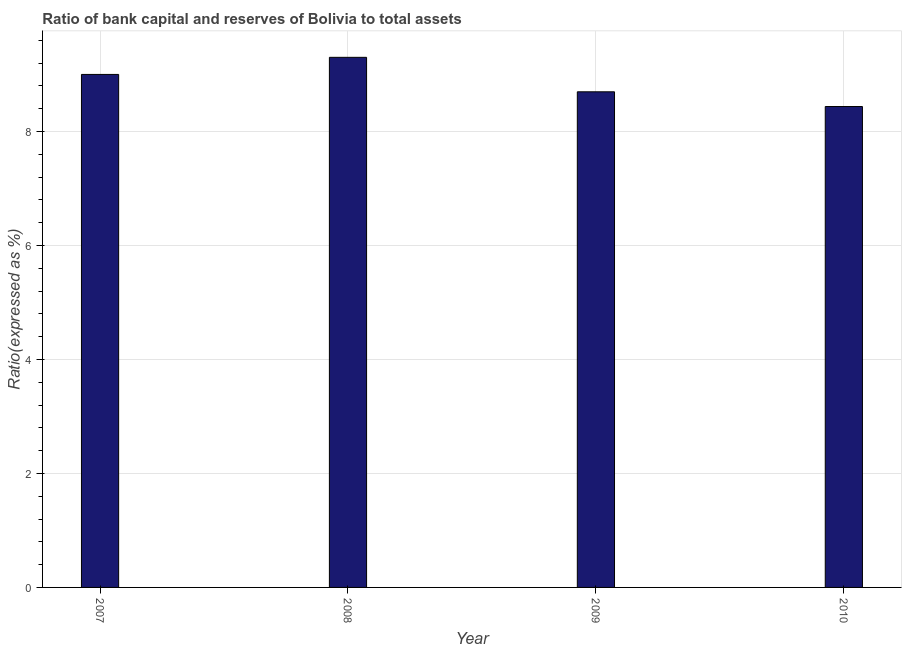What is the title of the graph?
Your answer should be very brief. Ratio of bank capital and reserves of Bolivia to total assets. What is the label or title of the Y-axis?
Provide a succinct answer. Ratio(expressed as %). Across all years, what is the maximum bank capital to assets ratio?
Your answer should be compact. 9.3. Across all years, what is the minimum bank capital to assets ratio?
Ensure brevity in your answer.  8.44. In which year was the bank capital to assets ratio maximum?
Your answer should be very brief. 2008. In which year was the bank capital to assets ratio minimum?
Offer a terse response. 2010. What is the sum of the bank capital to assets ratio?
Your answer should be very brief. 35.43. What is the difference between the bank capital to assets ratio in 2008 and 2010?
Your answer should be very brief. 0.86. What is the average bank capital to assets ratio per year?
Give a very brief answer. 8.86. What is the median bank capital to assets ratio?
Make the answer very short. 8.85. In how many years, is the bank capital to assets ratio greater than 2 %?
Your answer should be compact. 4. Do a majority of the years between 2008 and 2010 (inclusive) have bank capital to assets ratio greater than 8.4 %?
Make the answer very short. Yes. What is the ratio of the bank capital to assets ratio in 2007 to that in 2008?
Provide a short and direct response. 0.97. What is the difference between the highest and the second highest bank capital to assets ratio?
Provide a succinct answer. 0.3. What is the difference between the highest and the lowest bank capital to assets ratio?
Keep it short and to the point. 0.86. What is the difference between two consecutive major ticks on the Y-axis?
Give a very brief answer. 2. What is the Ratio(expressed as %) in 2007?
Provide a succinct answer. 9. What is the Ratio(expressed as %) of 2008?
Your answer should be compact. 9.3. What is the Ratio(expressed as %) of 2009?
Offer a terse response. 8.7. What is the Ratio(expressed as %) of 2010?
Your response must be concise. 8.44. What is the difference between the Ratio(expressed as %) in 2007 and 2009?
Your response must be concise. 0.3. What is the difference between the Ratio(expressed as %) in 2007 and 2010?
Ensure brevity in your answer.  0.56. What is the difference between the Ratio(expressed as %) in 2008 and 2009?
Provide a short and direct response. 0.6. What is the difference between the Ratio(expressed as %) in 2008 and 2010?
Offer a terse response. 0.86. What is the difference between the Ratio(expressed as %) in 2009 and 2010?
Keep it short and to the point. 0.26. What is the ratio of the Ratio(expressed as %) in 2007 to that in 2009?
Offer a terse response. 1.03. What is the ratio of the Ratio(expressed as %) in 2007 to that in 2010?
Provide a short and direct response. 1.07. What is the ratio of the Ratio(expressed as %) in 2008 to that in 2009?
Offer a terse response. 1.07. What is the ratio of the Ratio(expressed as %) in 2008 to that in 2010?
Keep it short and to the point. 1.1. What is the ratio of the Ratio(expressed as %) in 2009 to that in 2010?
Ensure brevity in your answer.  1.03. 